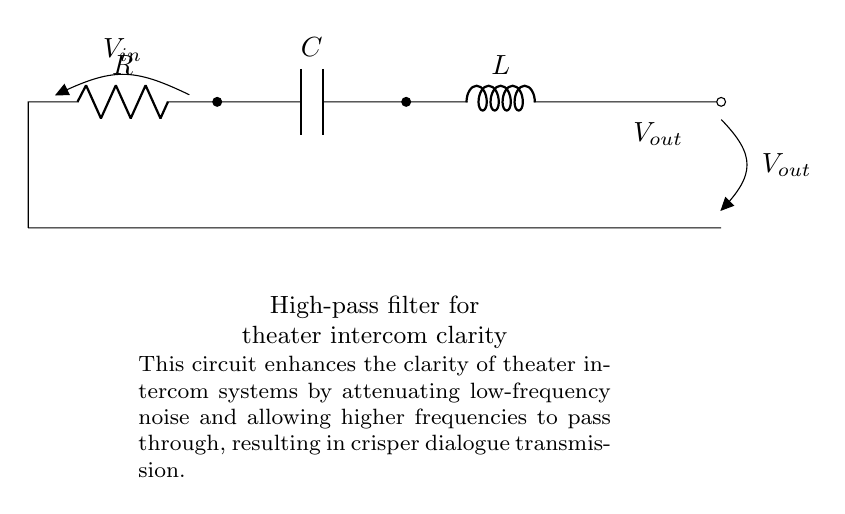What are the components present in this circuit? The components are a resistor, a capacitor, and an inductor. These elements are labeled in the circuit diagram and are arranged sequentially.
Answer: resistor, capacitor, inductor What is the function of the capacitor in this circuit? The capacitor blocks low-frequency signals while allowing high-frequency signals to pass through, which is essential for filtering out noise in audio systems.
Answer: block low-frequency signals What is the input voltage designated in the circuit? The input voltage is labeled V_in and is noted at the connection point to the resistor in the circuit.
Answer: V_in Explain the purpose of this high-pass filter in theater intercom systems. The high-pass filter's purpose is to improve audio clarity by reducing low-frequency noise, thus enhancing the intelligibility of speech transmitted through the intercom system.
Answer: improve audio clarity How does the inductor affect the high-pass filter's frequency response? The inductor contributes to the impedance at lower frequencies, allowing only higher frequencies to pass, thereby assisting the filter in attenuating undesired low-frequency signals.
Answer: attenuate low-frequency signals Which component is responsible for the output voltage in the circuit? The output voltage V_out is taken across the inductor, indicating that the voltage after the high-pass filter is characterized by higher frequency signals.
Answer: inductor 